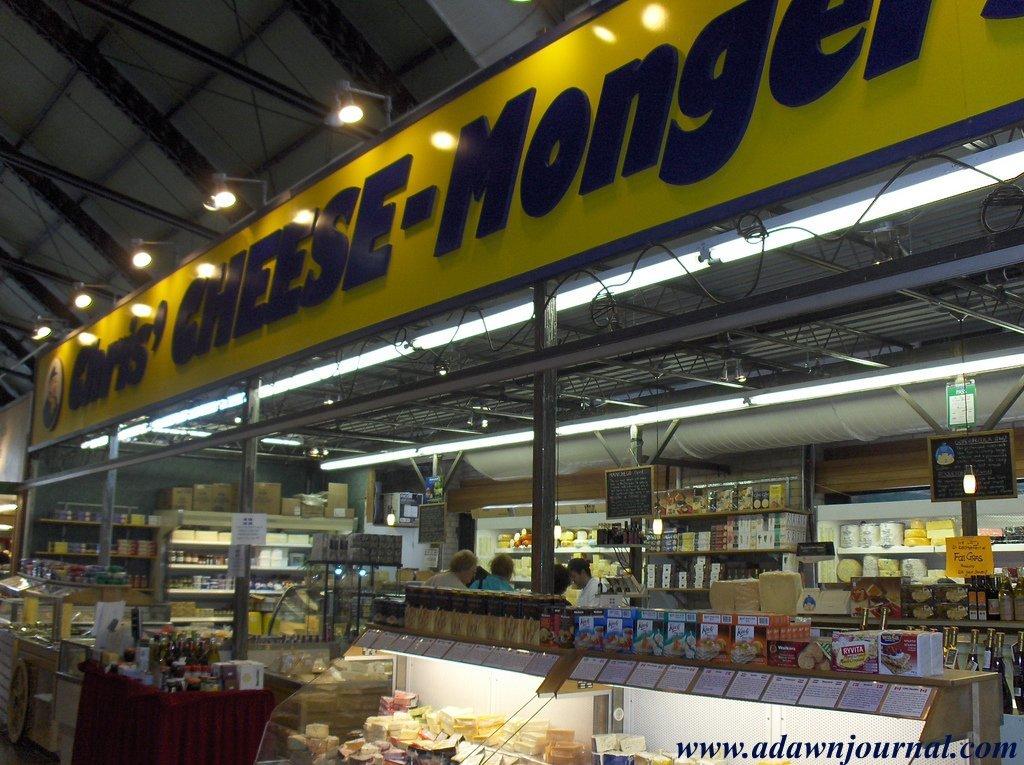Is this a food store?
Keep it short and to the point. Yes. What product is sold in this section?
Make the answer very short. Cheese. 